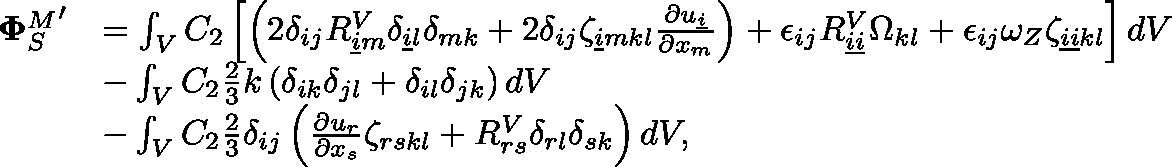Convert formula to latex. <formula><loc_0><loc_0><loc_500><loc_500>\begin{array} { r l } { { \Phi _ { S } ^ { M } } ^ { \prime } } & { = \int _ { V } C _ { 2 } \left [ \left ( 2 \delta _ { i j } R _ { \underline { i } m } ^ { V } \delta _ { \underline { i } l } \delta _ { m k } + 2 \delta _ { i j } \zeta _ { \underline { i } m k l } \frac { \partial u _ { \underline { i } } } { \partial x _ { m } } \right ) + \epsilon _ { i j } R _ { \underline { i } \underline { i } } ^ { V } \Omega _ { k l } + \epsilon _ { i j } \omega _ { Z } \zeta _ { \underline { i } \underline { i } k l } \right ] d V } \\ & { - \int _ { V } C _ { 2 } \frac { 2 } { 3 } k \left ( \delta _ { i k } \delta _ { j l } + \delta _ { i l } \delta _ { j k } \right ) d V } \\ & { - \int _ { V } C _ { 2 } \frac { 2 } { 3 } \delta _ { i j } \left ( \frac { \partial u _ { r } } { \partial x _ { s } } \zeta _ { r s k l } + R _ { r s } ^ { V } \delta _ { r l } \delta _ { s k } \right ) d V , } \end{array}</formula> 